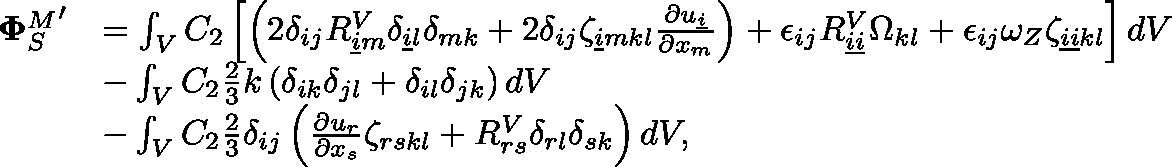Convert formula to latex. <formula><loc_0><loc_0><loc_500><loc_500>\begin{array} { r l } { { \Phi _ { S } ^ { M } } ^ { \prime } } & { = \int _ { V } C _ { 2 } \left [ \left ( 2 \delta _ { i j } R _ { \underline { i } m } ^ { V } \delta _ { \underline { i } l } \delta _ { m k } + 2 \delta _ { i j } \zeta _ { \underline { i } m k l } \frac { \partial u _ { \underline { i } } } { \partial x _ { m } } \right ) + \epsilon _ { i j } R _ { \underline { i } \underline { i } } ^ { V } \Omega _ { k l } + \epsilon _ { i j } \omega _ { Z } \zeta _ { \underline { i } \underline { i } k l } \right ] d V } \\ & { - \int _ { V } C _ { 2 } \frac { 2 } { 3 } k \left ( \delta _ { i k } \delta _ { j l } + \delta _ { i l } \delta _ { j k } \right ) d V } \\ & { - \int _ { V } C _ { 2 } \frac { 2 } { 3 } \delta _ { i j } \left ( \frac { \partial u _ { r } } { \partial x _ { s } } \zeta _ { r s k l } + R _ { r s } ^ { V } \delta _ { r l } \delta _ { s k } \right ) d V , } \end{array}</formula> 